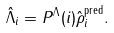<formula> <loc_0><loc_0><loc_500><loc_500>\hat { \Lambda } _ { i } = P ^ { \Lambda } ( i ) \hat { \rho } ^ { \text {pred} } _ { i } .</formula> 